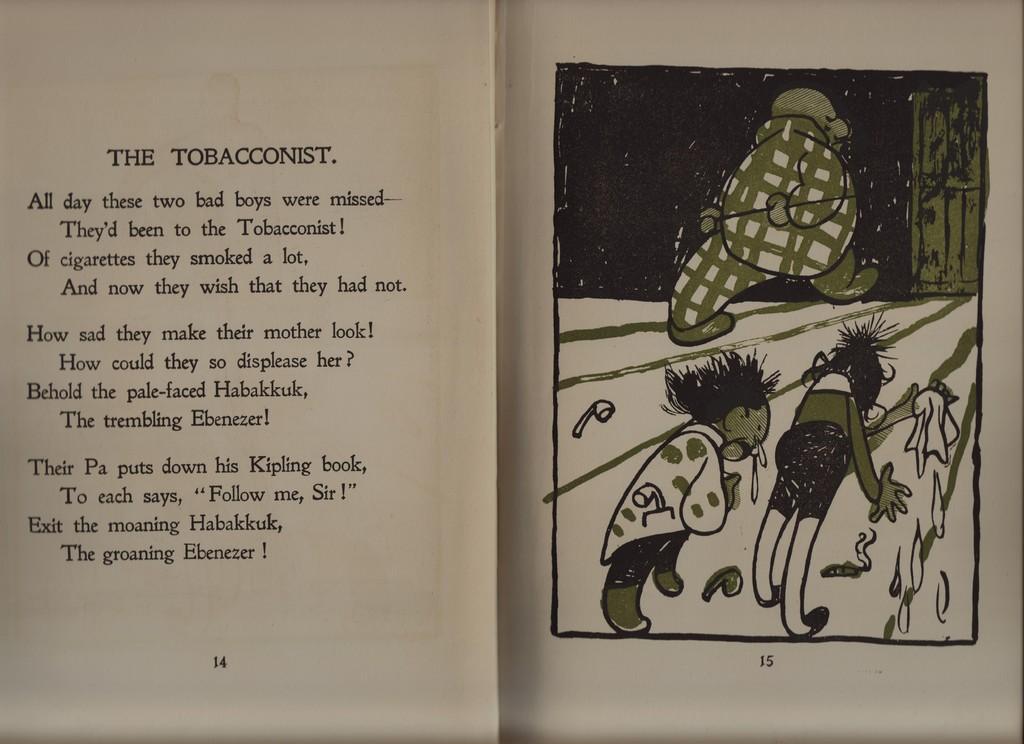What is the name of the poem?
Give a very brief answer. The tobacconist. What does the last line of the poem say?
Offer a terse response. The groaning ebenezzer. 